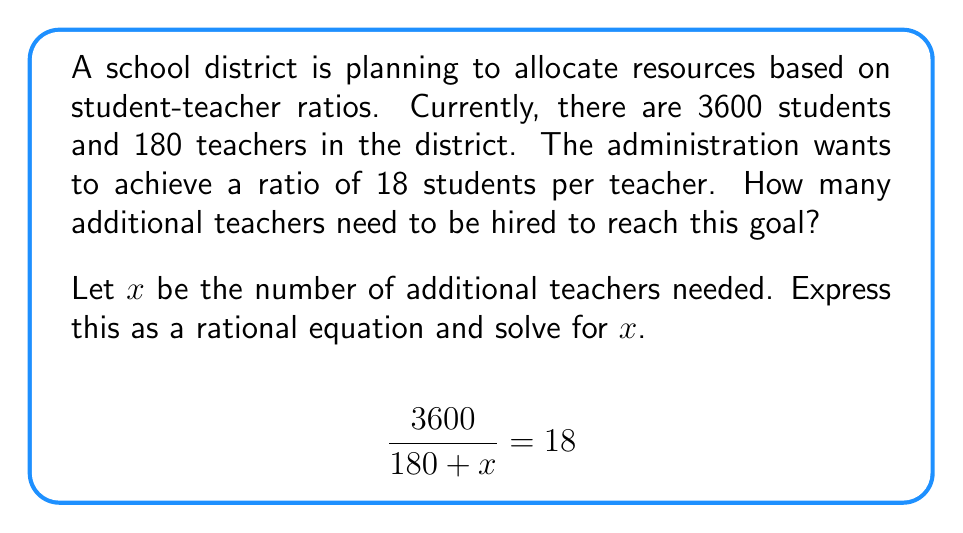Teach me how to tackle this problem. To solve this rational equation, we'll follow these steps:

1) Start with the given equation:
   $$\frac{3600}{180 + x} = 18$$

2) Multiply both sides by $(180 + x)$ to eliminate the fraction:
   $$(180 + x) \cdot \frac{3600}{180 + x} = (180 + x) \cdot 18$$
   $$3600 = 18(180 + x)$$

3) Distribute on the right side:
   $$3600 = 3240 + 18x$$

4) Subtract 3240 from both sides:
   $$360 = 18x$$

5) Divide both sides by 18:
   $$\frac{360}{18} = x$$
   $$20 = x$$

Therefore, the school district needs to hire 20 additional teachers to achieve the desired student-teacher ratio.

6) Verify the solution:
   With 20 additional teachers, the new ratio would be:
   $$\frac{3600}{180 + 20} = \frac{3600}{200} = 18$$

   This confirms our solution is correct.
Answer: 20 additional teachers 